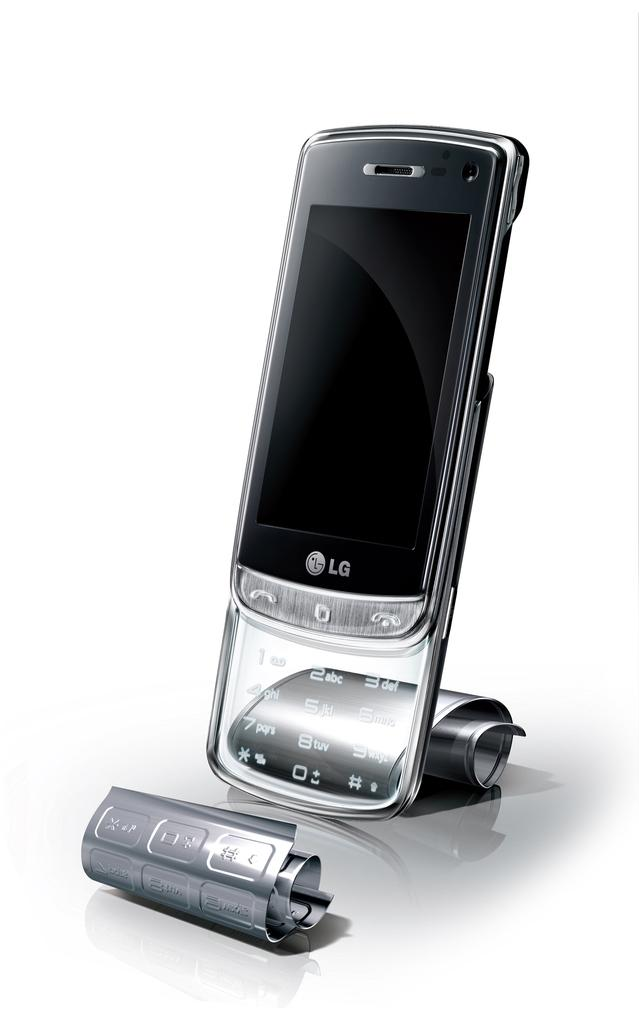<image>
Write a terse but informative summary of the picture. Silver cellphone with the letters LG under the screen. 